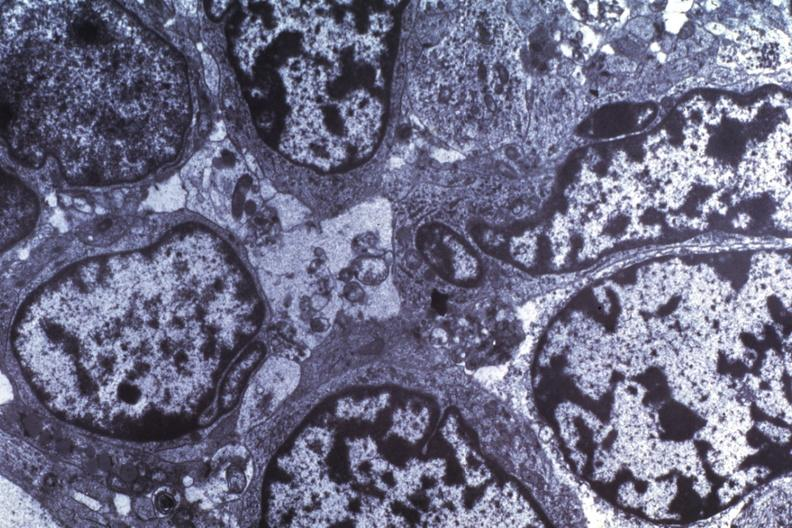what is present?
Answer the question using a single word or phrase. Brain 